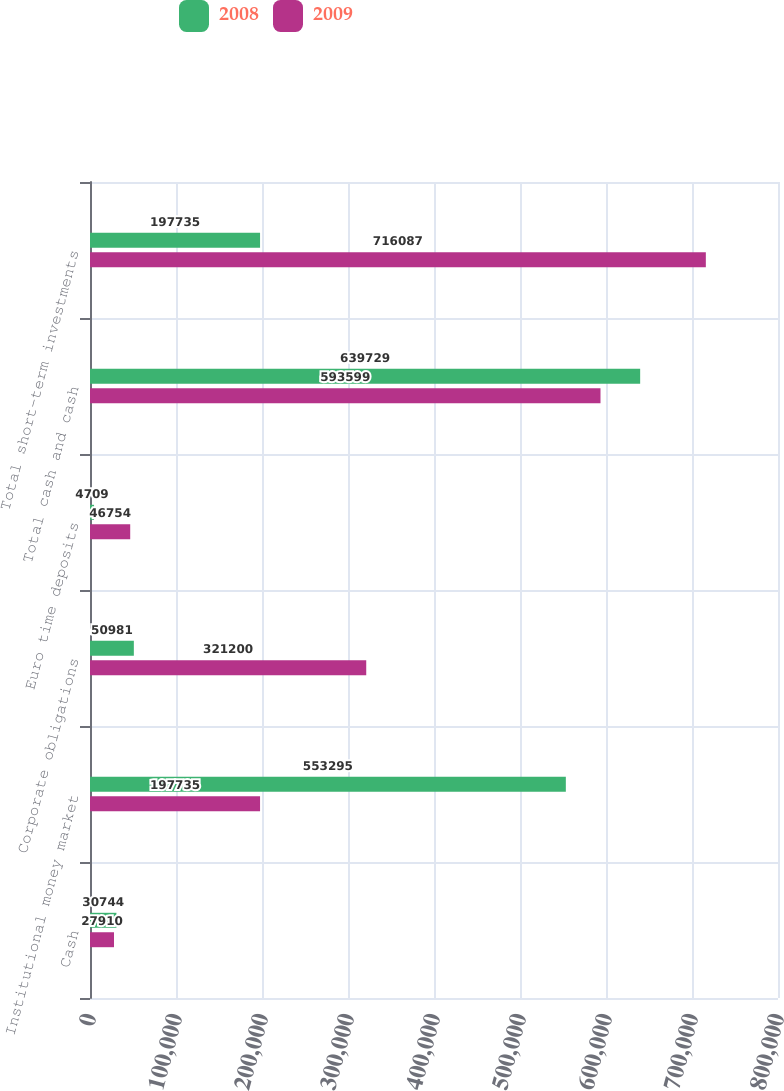<chart> <loc_0><loc_0><loc_500><loc_500><stacked_bar_chart><ecel><fcel>Cash<fcel>Institutional money market<fcel>Corporate obligations<fcel>Euro time deposits<fcel>Total cash and cash<fcel>Total short-term investments<nl><fcel>2008<fcel>30744<fcel>553295<fcel>50981<fcel>4709<fcel>639729<fcel>197735<nl><fcel>2009<fcel>27910<fcel>197735<fcel>321200<fcel>46754<fcel>593599<fcel>716087<nl></chart> 